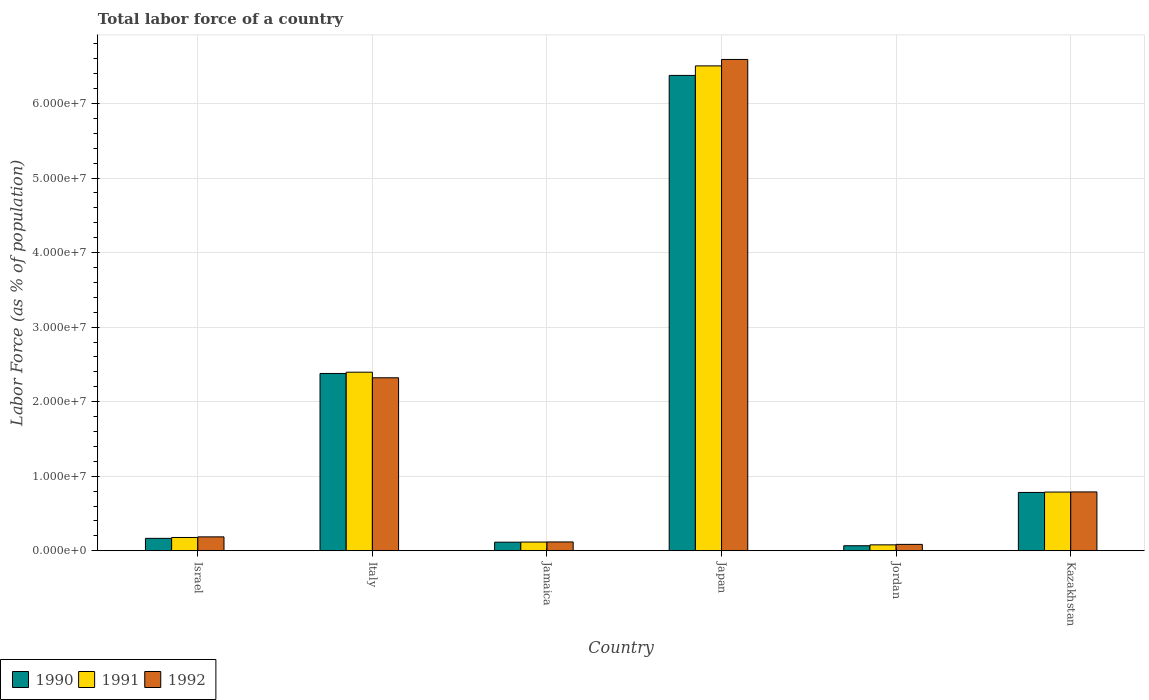Are the number of bars per tick equal to the number of legend labels?
Give a very brief answer. Yes. In how many cases, is the number of bars for a given country not equal to the number of legend labels?
Your answer should be very brief. 0. What is the percentage of labor force in 1992 in Israel?
Ensure brevity in your answer.  1.86e+06. Across all countries, what is the maximum percentage of labor force in 1991?
Offer a very short reply. 6.51e+07. Across all countries, what is the minimum percentage of labor force in 1991?
Keep it short and to the point. 7.87e+05. In which country was the percentage of labor force in 1990 minimum?
Your answer should be very brief. Jordan. What is the total percentage of labor force in 1992 in the graph?
Make the answer very short. 1.01e+08. What is the difference between the percentage of labor force in 1992 in Italy and that in Japan?
Make the answer very short. -4.27e+07. What is the difference between the percentage of labor force in 1990 in Japan and the percentage of labor force in 1992 in Italy?
Give a very brief answer. 4.06e+07. What is the average percentage of labor force in 1990 per country?
Offer a terse response. 1.65e+07. What is the difference between the percentage of labor force of/in 1992 and percentage of labor force of/in 1990 in Italy?
Keep it short and to the point. -5.81e+05. What is the ratio of the percentage of labor force in 1990 in Jamaica to that in Jordan?
Your answer should be compact. 1.72. Is the percentage of labor force in 1990 in Italy less than that in Jamaica?
Ensure brevity in your answer.  No. Is the difference between the percentage of labor force in 1992 in Japan and Kazakhstan greater than the difference between the percentage of labor force in 1990 in Japan and Kazakhstan?
Give a very brief answer. Yes. What is the difference between the highest and the second highest percentage of labor force in 1990?
Offer a very short reply. 4.00e+07. What is the difference between the highest and the lowest percentage of labor force in 1990?
Offer a very short reply. 6.31e+07. In how many countries, is the percentage of labor force in 1992 greater than the average percentage of labor force in 1992 taken over all countries?
Keep it short and to the point. 2. Is the sum of the percentage of labor force in 1992 in Italy and Japan greater than the maximum percentage of labor force in 1991 across all countries?
Make the answer very short. Yes. What does the 2nd bar from the left in Jamaica represents?
Your answer should be compact. 1991. What does the 3rd bar from the right in Israel represents?
Your answer should be very brief. 1990. How many countries are there in the graph?
Offer a terse response. 6. Does the graph contain grids?
Your answer should be very brief. Yes. How are the legend labels stacked?
Ensure brevity in your answer.  Horizontal. What is the title of the graph?
Make the answer very short. Total labor force of a country. Does "1962" appear as one of the legend labels in the graph?
Your response must be concise. No. What is the label or title of the Y-axis?
Keep it short and to the point. Labor Force (as % of population). What is the Labor Force (as % of population) of 1990 in Israel?
Make the answer very short. 1.66e+06. What is the Labor Force (as % of population) in 1991 in Israel?
Your response must be concise. 1.78e+06. What is the Labor Force (as % of population) in 1992 in Israel?
Keep it short and to the point. 1.86e+06. What is the Labor Force (as % of population) in 1990 in Italy?
Ensure brevity in your answer.  2.38e+07. What is the Labor Force (as % of population) in 1991 in Italy?
Offer a very short reply. 2.40e+07. What is the Labor Force (as % of population) in 1992 in Italy?
Provide a succinct answer. 2.32e+07. What is the Labor Force (as % of population) of 1990 in Jamaica?
Your answer should be compact. 1.15e+06. What is the Labor Force (as % of population) in 1991 in Jamaica?
Your answer should be very brief. 1.16e+06. What is the Labor Force (as % of population) of 1992 in Jamaica?
Make the answer very short. 1.18e+06. What is the Labor Force (as % of population) in 1990 in Japan?
Your response must be concise. 6.38e+07. What is the Labor Force (as % of population) in 1991 in Japan?
Give a very brief answer. 6.51e+07. What is the Labor Force (as % of population) in 1992 in Japan?
Offer a terse response. 6.59e+07. What is the Labor Force (as % of population) in 1990 in Jordan?
Offer a very short reply. 6.68e+05. What is the Labor Force (as % of population) in 1991 in Jordan?
Ensure brevity in your answer.  7.87e+05. What is the Labor Force (as % of population) in 1992 in Jordan?
Offer a terse response. 8.51e+05. What is the Labor Force (as % of population) in 1990 in Kazakhstan?
Keep it short and to the point. 7.82e+06. What is the Labor Force (as % of population) in 1991 in Kazakhstan?
Give a very brief answer. 7.87e+06. What is the Labor Force (as % of population) in 1992 in Kazakhstan?
Provide a short and direct response. 7.89e+06. Across all countries, what is the maximum Labor Force (as % of population) of 1990?
Your answer should be compact. 6.38e+07. Across all countries, what is the maximum Labor Force (as % of population) in 1991?
Your response must be concise. 6.51e+07. Across all countries, what is the maximum Labor Force (as % of population) in 1992?
Give a very brief answer. 6.59e+07. Across all countries, what is the minimum Labor Force (as % of population) of 1990?
Provide a succinct answer. 6.68e+05. Across all countries, what is the minimum Labor Force (as % of population) of 1991?
Ensure brevity in your answer.  7.87e+05. Across all countries, what is the minimum Labor Force (as % of population) of 1992?
Offer a terse response. 8.51e+05. What is the total Labor Force (as % of population) in 1990 in the graph?
Ensure brevity in your answer.  9.89e+07. What is the total Labor Force (as % of population) of 1991 in the graph?
Keep it short and to the point. 1.01e+08. What is the total Labor Force (as % of population) of 1992 in the graph?
Offer a very short reply. 1.01e+08. What is the difference between the Labor Force (as % of population) in 1990 in Israel and that in Italy?
Ensure brevity in your answer.  -2.21e+07. What is the difference between the Labor Force (as % of population) in 1991 in Israel and that in Italy?
Offer a very short reply. -2.22e+07. What is the difference between the Labor Force (as % of population) in 1992 in Israel and that in Italy?
Make the answer very short. -2.13e+07. What is the difference between the Labor Force (as % of population) in 1990 in Israel and that in Jamaica?
Offer a terse response. 5.13e+05. What is the difference between the Labor Force (as % of population) of 1991 in Israel and that in Jamaica?
Your response must be concise. 6.14e+05. What is the difference between the Labor Force (as % of population) of 1992 in Israel and that in Jamaica?
Your answer should be compact. 6.81e+05. What is the difference between the Labor Force (as % of population) of 1990 in Israel and that in Japan?
Your answer should be very brief. -6.21e+07. What is the difference between the Labor Force (as % of population) in 1991 in Israel and that in Japan?
Make the answer very short. -6.33e+07. What is the difference between the Labor Force (as % of population) of 1992 in Israel and that in Japan?
Provide a short and direct response. -6.41e+07. What is the difference between the Labor Force (as % of population) of 1990 in Israel and that in Jordan?
Keep it short and to the point. 9.91e+05. What is the difference between the Labor Force (as % of population) in 1991 in Israel and that in Jordan?
Make the answer very short. 9.89e+05. What is the difference between the Labor Force (as % of population) of 1992 in Israel and that in Jordan?
Provide a succinct answer. 1.01e+06. What is the difference between the Labor Force (as % of population) of 1990 in Israel and that in Kazakhstan?
Ensure brevity in your answer.  -6.16e+06. What is the difference between the Labor Force (as % of population) in 1991 in Israel and that in Kazakhstan?
Provide a succinct answer. -6.10e+06. What is the difference between the Labor Force (as % of population) in 1992 in Israel and that in Kazakhstan?
Provide a short and direct response. -6.03e+06. What is the difference between the Labor Force (as % of population) in 1990 in Italy and that in Jamaica?
Provide a short and direct response. 2.26e+07. What is the difference between the Labor Force (as % of population) in 1991 in Italy and that in Jamaica?
Your answer should be compact. 2.28e+07. What is the difference between the Labor Force (as % of population) of 1992 in Italy and that in Jamaica?
Your answer should be compact. 2.20e+07. What is the difference between the Labor Force (as % of population) in 1990 in Italy and that in Japan?
Your answer should be very brief. -4.00e+07. What is the difference between the Labor Force (as % of population) of 1991 in Italy and that in Japan?
Make the answer very short. -4.11e+07. What is the difference between the Labor Force (as % of population) in 1992 in Italy and that in Japan?
Offer a very short reply. -4.27e+07. What is the difference between the Labor Force (as % of population) in 1990 in Italy and that in Jordan?
Make the answer very short. 2.31e+07. What is the difference between the Labor Force (as % of population) in 1991 in Italy and that in Jordan?
Your answer should be very brief. 2.32e+07. What is the difference between the Labor Force (as % of population) in 1992 in Italy and that in Jordan?
Give a very brief answer. 2.24e+07. What is the difference between the Labor Force (as % of population) of 1990 in Italy and that in Kazakhstan?
Give a very brief answer. 1.60e+07. What is the difference between the Labor Force (as % of population) in 1991 in Italy and that in Kazakhstan?
Make the answer very short. 1.61e+07. What is the difference between the Labor Force (as % of population) of 1992 in Italy and that in Kazakhstan?
Your response must be concise. 1.53e+07. What is the difference between the Labor Force (as % of population) in 1990 in Jamaica and that in Japan?
Provide a short and direct response. -6.26e+07. What is the difference between the Labor Force (as % of population) of 1991 in Jamaica and that in Japan?
Your answer should be compact. -6.39e+07. What is the difference between the Labor Force (as % of population) in 1992 in Jamaica and that in Japan?
Provide a succinct answer. -6.47e+07. What is the difference between the Labor Force (as % of population) in 1990 in Jamaica and that in Jordan?
Ensure brevity in your answer.  4.78e+05. What is the difference between the Labor Force (as % of population) in 1991 in Jamaica and that in Jordan?
Provide a succinct answer. 3.76e+05. What is the difference between the Labor Force (as % of population) in 1992 in Jamaica and that in Jordan?
Make the answer very short. 3.26e+05. What is the difference between the Labor Force (as % of population) of 1990 in Jamaica and that in Kazakhstan?
Offer a very short reply. -6.67e+06. What is the difference between the Labor Force (as % of population) of 1991 in Jamaica and that in Kazakhstan?
Your response must be concise. -6.71e+06. What is the difference between the Labor Force (as % of population) of 1992 in Jamaica and that in Kazakhstan?
Your answer should be very brief. -6.71e+06. What is the difference between the Labor Force (as % of population) of 1990 in Japan and that in Jordan?
Your response must be concise. 6.31e+07. What is the difference between the Labor Force (as % of population) in 1991 in Japan and that in Jordan?
Provide a succinct answer. 6.43e+07. What is the difference between the Labor Force (as % of population) in 1992 in Japan and that in Jordan?
Ensure brevity in your answer.  6.51e+07. What is the difference between the Labor Force (as % of population) of 1990 in Japan and that in Kazakhstan?
Provide a succinct answer. 5.60e+07. What is the difference between the Labor Force (as % of population) in 1991 in Japan and that in Kazakhstan?
Your answer should be compact. 5.72e+07. What is the difference between the Labor Force (as % of population) in 1992 in Japan and that in Kazakhstan?
Give a very brief answer. 5.80e+07. What is the difference between the Labor Force (as % of population) of 1990 in Jordan and that in Kazakhstan?
Offer a terse response. -7.15e+06. What is the difference between the Labor Force (as % of population) in 1991 in Jordan and that in Kazakhstan?
Offer a very short reply. -7.08e+06. What is the difference between the Labor Force (as % of population) in 1992 in Jordan and that in Kazakhstan?
Provide a succinct answer. -7.04e+06. What is the difference between the Labor Force (as % of population) in 1990 in Israel and the Labor Force (as % of population) in 1991 in Italy?
Your response must be concise. -2.23e+07. What is the difference between the Labor Force (as % of population) of 1990 in Israel and the Labor Force (as % of population) of 1992 in Italy?
Your response must be concise. -2.15e+07. What is the difference between the Labor Force (as % of population) of 1991 in Israel and the Labor Force (as % of population) of 1992 in Italy?
Your answer should be very brief. -2.14e+07. What is the difference between the Labor Force (as % of population) in 1990 in Israel and the Labor Force (as % of population) in 1991 in Jamaica?
Offer a very short reply. 4.97e+05. What is the difference between the Labor Force (as % of population) in 1990 in Israel and the Labor Force (as % of population) in 1992 in Jamaica?
Keep it short and to the point. 4.82e+05. What is the difference between the Labor Force (as % of population) in 1991 in Israel and the Labor Force (as % of population) in 1992 in Jamaica?
Give a very brief answer. 5.99e+05. What is the difference between the Labor Force (as % of population) in 1990 in Israel and the Labor Force (as % of population) in 1991 in Japan?
Offer a very short reply. -6.34e+07. What is the difference between the Labor Force (as % of population) of 1990 in Israel and the Labor Force (as % of population) of 1992 in Japan?
Your answer should be very brief. -6.43e+07. What is the difference between the Labor Force (as % of population) of 1991 in Israel and the Labor Force (as % of population) of 1992 in Japan?
Keep it short and to the point. -6.41e+07. What is the difference between the Labor Force (as % of population) in 1990 in Israel and the Labor Force (as % of population) in 1991 in Jordan?
Provide a succinct answer. 8.72e+05. What is the difference between the Labor Force (as % of population) of 1990 in Israel and the Labor Force (as % of population) of 1992 in Jordan?
Provide a short and direct response. 8.08e+05. What is the difference between the Labor Force (as % of population) in 1991 in Israel and the Labor Force (as % of population) in 1992 in Jordan?
Make the answer very short. 9.25e+05. What is the difference between the Labor Force (as % of population) of 1990 in Israel and the Labor Force (as % of population) of 1991 in Kazakhstan?
Keep it short and to the point. -6.21e+06. What is the difference between the Labor Force (as % of population) of 1990 in Israel and the Labor Force (as % of population) of 1992 in Kazakhstan?
Make the answer very short. -6.23e+06. What is the difference between the Labor Force (as % of population) in 1991 in Israel and the Labor Force (as % of population) in 1992 in Kazakhstan?
Provide a succinct answer. -6.11e+06. What is the difference between the Labor Force (as % of population) in 1990 in Italy and the Labor Force (as % of population) in 1991 in Jamaica?
Ensure brevity in your answer.  2.26e+07. What is the difference between the Labor Force (as % of population) in 1990 in Italy and the Labor Force (as % of population) in 1992 in Jamaica?
Provide a succinct answer. 2.26e+07. What is the difference between the Labor Force (as % of population) in 1991 in Italy and the Labor Force (as % of population) in 1992 in Jamaica?
Make the answer very short. 2.28e+07. What is the difference between the Labor Force (as % of population) in 1990 in Italy and the Labor Force (as % of population) in 1991 in Japan?
Make the answer very short. -4.13e+07. What is the difference between the Labor Force (as % of population) in 1990 in Italy and the Labor Force (as % of population) in 1992 in Japan?
Make the answer very short. -4.21e+07. What is the difference between the Labor Force (as % of population) of 1991 in Italy and the Labor Force (as % of population) of 1992 in Japan?
Make the answer very short. -4.20e+07. What is the difference between the Labor Force (as % of population) of 1990 in Italy and the Labor Force (as % of population) of 1991 in Jordan?
Give a very brief answer. 2.30e+07. What is the difference between the Labor Force (as % of population) of 1990 in Italy and the Labor Force (as % of population) of 1992 in Jordan?
Provide a short and direct response. 2.29e+07. What is the difference between the Labor Force (as % of population) in 1991 in Italy and the Labor Force (as % of population) in 1992 in Jordan?
Ensure brevity in your answer.  2.31e+07. What is the difference between the Labor Force (as % of population) in 1990 in Italy and the Labor Force (as % of population) in 1991 in Kazakhstan?
Your answer should be compact. 1.59e+07. What is the difference between the Labor Force (as % of population) of 1990 in Italy and the Labor Force (as % of population) of 1992 in Kazakhstan?
Keep it short and to the point. 1.59e+07. What is the difference between the Labor Force (as % of population) of 1991 in Italy and the Labor Force (as % of population) of 1992 in Kazakhstan?
Give a very brief answer. 1.61e+07. What is the difference between the Labor Force (as % of population) in 1990 in Jamaica and the Labor Force (as % of population) in 1991 in Japan?
Offer a very short reply. -6.39e+07. What is the difference between the Labor Force (as % of population) in 1990 in Jamaica and the Labor Force (as % of population) in 1992 in Japan?
Provide a short and direct response. -6.48e+07. What is the difference between the Labor Force (as % of population) of 1991 in Jamaica and the Labor Force (as % of population) of 1992 in Japan?
Provide a short and direct response. -6.48e+07. What is the difference between the Labor Force (as % of population) in 1990 in Jamaica and the Labor Force (as % of population) in 1991 in Jordan?
Offer a terse response. 3.60e+05. What is the difference between the Labor Force (as % of population) of 1990 in Jamaica and the Labor Force (as % of population) of 1992 in Jordan?
Offer a very short reply. 2.95e+05. What is the difference between the Labor Force (as % of population) in 1991 in Jamaica and the Labor Force (as % of population) in 1992 in Jordan?
Provide a succinct answer. 3.11e+05. What is the difference between the Labor Force (as % of population) in 1990 in Jamaica and the Labor Force (as % of population) in 1991 in Kazakhstan?
Ensure brevity in your answer.  -6.72e+06. What is the difference between the Labor Force (as % of population) of 1990 in Jamaica and the Labor Force (as % of population) of 1992 in Kazakhstan?
Your answer should be very brief. -6.74e+06. What is the difference between the Labor Force (as % of population) in 1991 in Jamaica and the Labor Force (as % of population) in 1992 in Kazakhstan?
Offer a very short reply. -6.73e+06. What is the difference between the Labor Force (as % of population) in 1990 in Japan and the Labor Force (as % of population) in 1991 in Jordan?
Give a very brief answer. 6.30e+07. What is the difference between the Labor Force (as % of population) in 1990 in Japan and the Labor Force (as % of population) in 1992 in Jordan?
Provide a succinct answer. 6.29e+07. What is the difference between the Labor Force (as % of population) of 1991 in Japan and the Labor Force (as % of population) of 1992 in Jordan?
Your response must be concise. 6.42e+07. What is the difference between the Labor Force (as % of population) in 1990 in Japan and the Labor Force (as % of population) in 1991 in Kazakhstan?
Offer a very short reply. 5.59e+07. What is the difference between the Labor Force (as % of population) in 1990 in Japan and the Labor Force (as % of population) in 1992 in Kazakhstan?
Provide a short and direct response. 5.59e+07. What is the difference between the Labor Force (as % of population) in 1991 in Japan and the Labor Force (as % of population) in 1992 in Kazakhstan?
Offer a terse response. 5.72e+07. What is the difference between the Labor Force (as % of population) in 1990 in Jordan and the Labor Force (as % of population) in 1991 in Kazakhstan?
Provide a succinct answer. -7.20e+06. What is the difference between the Labor Force (as % of population) in 1990 in Jordan and the Labor Force (as % of population) in 1992 in Kazakhstan?
Your response must be concise. -7.22e+06. What is the difference between the Labor Force (as % of population) in 1991 in Jordan and the Labor Force (as % of population) in 1992 in Kazakhstan?
Ensure brevity in your answer.  -7.10e+06. What is the average Labor Force (as % of population) of 1990 per country?
Your answer should be very brief. 1.65e+07. What is the average Labor Force (as % of population) of 1991 per country?
Your answer should be compact. 1.68e+07. What is the average Labor Force (as % of population) of 1992 per country?
Make the answer very short. 1.68e+07. What is the difference between the Labor Force (as % of population) of 1990 and Labor Force (as % of population) of 1991 in Israel?
Your answer should be very brief. -1.17e+05. What is the difference between the Labor Force (as % of population) in 1990 and Labor Force (as % of population) in 1992 in Israel?
Your response must be concise. -1.99e+05. What is the difference between the Labor Force (as % of population) in 1991 and Labor Force (as % of population) in 1992 in Israel?
Give a very brief answer. -8.20e+04. What is the difference between the Labor Force (as % of population) of 1990 and Labor Force (as % of population) of 1991 in Italy?
Your answer should be compact. -1.70e+05. What is the difference between the Labor Force (as % of population) of 1990 and Labor Force (as % of population) of 1992 in Italy?
Ensure brevity in your answer.  5.81e+05. What is the difference between the Labor Force (as % of population) of 1991 and Labor Force (as % of population) of 1992 in Italy?
Provide a short and direct response. 7.51e+05. What is the difference between the Labor Force (as % of population) in 1990 and Labor Force (as % of population) in 1991 in Jamaica?
Give a very brief answer. -1.61e+04. What is the difference between the Labor Force (as % of population) in 1990 and Labor Force (as % of population) in 1992 in Jamaica?
Make the answer very short. -3.05e+04. What is the difference between the Labor Force (as % of population) of 1991 and Labor Force (as % of population) of 1992 in Jamaica?
Your answer should be compact. -1.44e+04. What is the difference between the Labor Force (as % of population) in 1990 and Labor Force (as % of population) in 1991 in Japan?
Keep it short and to the point. -1.28e+06. What is the difference between the Labor Force (as % of population) of 1990 and Labor Force (as % of population) of 1992 in Japan?
Your answer should be very brief. -2.14e+06. What is the difference between the Labor Force (as % of population) of 1991 and Labor Force (as % of population) of 1992 in Japan?
Your answer should be compact. -8.65e+05. What is the difference between the Labor Force (as % of population) in 1990 and Labor Force (as % of population) in 1991 in Jordan?
Your response must be concise. -1.19e+05. What is the difference between the Labor Force (as % of population) of 1990 and Labor Force (as % of population) of 1992 in Jordan?
Offer a terse response. -1.83e+05. What is the difference between the Labor Force (as % of population) of 1991 and Labor Force (as % of population) of 1992 in Jordan?
Keep it short and to the point. -6.44e+04. What is the difference between the Labor Force (as % of population) of 1990 and Labor Force (as % of population) of 1991 in Kazakhstan?
Offer a terse response. -5.15e+04. What is the difference between the Labor Force (as % of population) in 1990 and Labor Force (as % of population) in 1992 in Kazakhstan?
Ensure brevity in your answer.  -6.94e+04. What is the difference between the Labor Force (as % of population) of 1991 and Labor Force (as % of population) of 1992 in Kazakhstan?
Provide a short and direct response. -1.79e+04. What is the ratio of the Labor Force (as % of population) of 1990 in Israel to that in Italy?
Your answer should be very brief. 0.07. What is the ratio of the Labor Force (as % of population) in 1991 in Israel to that in Italy?
Your answer should be compact. 0.07. What is the ratio of the Labor Force (as % of population) of 1992 in Israel to that in Italy?
Keep it short and to the point. 0.08. What is the ratio of the Labor Force (as % of population) of 1990 in Israel to that in Jamaica?
Make the answer very short. 1.45. What is the ratio of the Labor Force (as % of population) of 1991 in Israel to that in Jamaica?
Provide a short and direct response. 1.53. What is the ratio of the Labor Force (as % of population) in 1992 in Israel to that in Jamaica?
Provide a succinct answer. 1.58. What is the ratio of the Labor Force (as % of population) of 1990 in Israel to that in Japan?
Give a very brief answer. 0.03. What is the ratio of the Labor Force (as % of population) of 1991 in Israel to that in Japan?
Your answer should be compact. 0.03. What is the ratio of the Labor Force (as % of population) in 1992 in Israel to that in Japan?
Give a very brief answer. 0.03. What is the ratio of the Labor Force (as % of population) in 1990 in Israel to that in Jordan?
Offer a terse response. 2.48. What is the ratio of the Labor Force (as % of population) in 1991 in Israel to that in Jordan?
Your response must be concise. 2.26. What is the ratio of the Labor Force (as % of population) of 1992 in Israel to that in Jordan?
Keep it short and to the point. 2.18. What is the ratio of the Labor Force (as % of population) of 1990 in Israel to that in Kazakhstan?
Your answer should be very brief. 0.21. What is the ratio of the Labor Force (as % of population) in 1991 in Israel to that in Kazakhstan?
Give a very brief answer. 0.23. What is the ratio of the Labor Force (as % of population) in 1992 in Israel to that in Kazakhstan?
Provide a succinct answer. 0.24. What is the ratio of the Labor Force (as % of population) in 1990 in Italy to that in Jamaica?
Give a very brief answer. 20.74. What is the ratio of the Labor Force (as % of population) in 1991 in Italy to that in Jamaica?
Ensure brevity in your answer.  20.6. What is the ratio of the Labor Force (as % of population) of 1992 in Italy to that in Jamaica?
Offer a terse response. 19.71. What is the ratio of the Labor Force (as % of population) in 1990 in Italy to that in Japan?
Your answer should be very brief. 0.37. What is the ratio of the Labor Force (as % of population) in 1991 in Italy to that in Japan?
Provide a succinct answer. 0.37. What is the ratio of the Labor Force (as % of population) in 1992 in Italy to that in Japan?
Your answer should be compact. 0.35. What is the ratio of the Labor Force (as % of population) of 1990 in Italy to that in Jordan?
Keep it short and to the point. 35.58. What is the ratio of the Labor Force (as % of population) of 1991 in Italy to that in Jordan?
Make the answer very short. 30.44. What is the ratio of the Labor Force (as % of population) in 1992 in Italy to that in Jordan?
Provide a short and direct response. 27.26. What is the ratio of the Labor Force (as % of population) in 1990 in Italy to that in Kazakhstan?
Your response must be concise. 3.04. What is the ratio of the Labor Force (as % of population) of 1991 in Italy to that in Kazakhstan?
Your answer should be compact. 3.04. What is the ratio of the Labor Force (as % of population) of 1992 in Italy to that in Kazakhstan?
Your response must be concise. 2.94. What is the ratio of the Labor Force (as % of population) of 1990 in Jamaica to that in Japan?
Keep it short and to the point. 0.02. What is the ratio of the Labor Force (as % of population) of 1991 in Jamaica to that in Japan?
Offer a terse response. 0.02. What is the ratio of the Labor Force (as % of population) in 1992 in Jamaica to that in Japan?
Offer a very short reply. 0.02. What is the ratio of the Labor Force (as % of population) in 1990 in Jamaica to that in Jordan?
Give a very brief answer. 1.72. What is the ratio of the Labor Force (as % of population) in 1991 in Jamaica to that in Jordan?
Your answer should be very brief. 1.48. What is the ratio of the Labor Force (as % of population) of 1992 in Jamaica to that in Jordan?
Offer a very short reply. 1.38. What is the ratio of the Labor Force (as % of population) in 1990 in Jamaica to that in Kazakhstan?
Offer a terse response. 0.15. What is the ratio of the Labor Force (as % of population) of 1991 in Jamaica to that in Kazakhstan?
Offer a terse response. 0.15. What is the ratio of the Labor Force (as % of population) in 1992 in Jamaica to that in Kazakhstan?
Provide a succinct answer. 0.15. What is the ratio of the Labor Force (as % of population) in 1990 in Japan to that in Jordan?
Offer a terse response. 95.42. What is the ratio of the Labor Force (as % of population) in 1991 in Japan to that in Jordan?
Keep it short and to the point. 82.67. What is the ratio of the Labor Force (as % of population) of 1992 in Japan to that in Jordan?
Offer a terse response. 77.44. What is the ratio of the Labor Force (as % of population) in 1990 in Japan to that in Kazakhstan?
Give a very brief answer. 8.16. What is the ratio of the Labor Force (as % of population) in 1991 in Japan to that in Kazakhstan?
Make the answer very short. 8.26. What is the ratio of the Labor Force (as % of population) of 1992 in Japan to that in Kazakhstan?
Keep it short and to the point. 8.36. What is the ratio of the Labor Force (as % of population) in 1990 in Jordan to that in Kazakhstan?
Provide a short and direct response. 0.09. What is the ratio of the Labor Force (as % of population) of 1991 in Jordan to that in Kazakhstan?
Offer a terse response. 0.1. What is the ratio of the Labor Force (as % of population) in 1992 in Jordan to that in Kazakhstan?
Offer a terse response. 0.11. What is the difference between the highest and the second highest Labor Force (as % of population) of 1990?
Ensure brevity in your answer.  4.00e+07. What is the difference between the highest and the second highest Labor Force (as % of population) of 1991?
Offer a very short reply. 4.11e+07. What is the difference between the highest and the second highest Labor Force (as % of population) in 1992?
Your answer should be very brief. 4.27e+07. What is the difference between the highest and the lowest Labor Force (as % of population) of 1990?
Give a very brief answer. 6.31e+07. What is the difference between the highest and the lowest Labor Force (as % of population) in 1991?
Your answer should be compact. 6.43e+07. What is the difference between the highest and the lowest Labor Force (as % of population) in 1992?
Provide a short and direct response. 6.51e+07. 